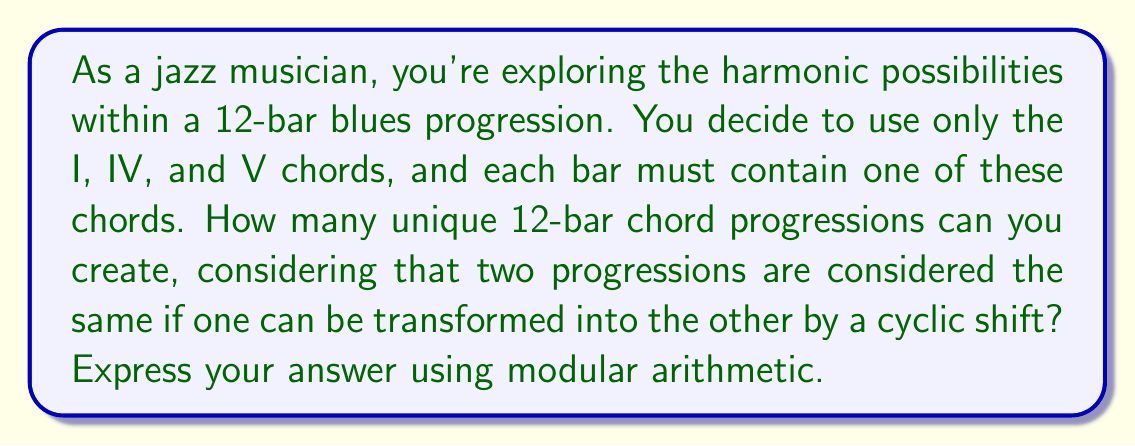Give your solution to this math problem. Let's approach this step-by-step:

1) First, without considering cyclic shifts, we have 3 choices (I, IV, or V) for each of the 12 bars. This would give us $3^{12}$ total possibilities.

2) However, we need to account for cyclic shifts. In modular arithmetic, this is equivalent to considering these progressions modulo 12 (mod 12).

3) The number of unique progressions will be the total number of progressions divided by the number of possible shifts (which is 12).

4) In modular arithmetic, this is expressed as:

   $$\frac{3^{12}}{12} \pmod{3^{12}}$$

5) We can simplify this further:
   
   $$\frac{3^{12}}{12} = 3^{12} \cdot 12^{-1} \pmod{3^{12}}$$

6) To find $12^{-1} \pmod{3^{12}}$, we need to find a number $x$ such that $12x \equiv 1 \pmod{3^{12}}$.

7) We can use the extended Euclidean algorithm to find this. The result is:

   $$12^{-1} \equiv 177147 \pmod{3^{12}}$$

8) Therefore, the final calculation is:

   $$3^{12} \cdot 177147 \pmod{3^{12}}$$

9) This evaluates to:

   $$531441 \pmod{3^{12}}$$
Answer: $531441$ 